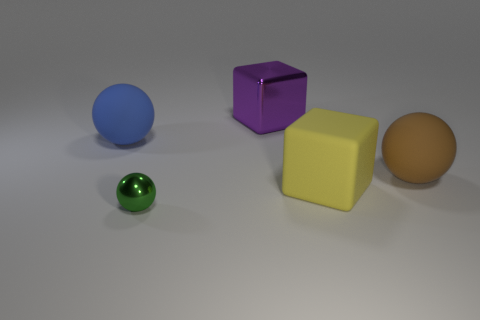Add 5 brown rubber objects. How many objects exist? 10 Subtract all spheres. How many objects are left? 2 Add 4 large purple metallic blocks. How many large purple metallic blocks exist? 5 Subtract 0 red spheres. How many objects are left? 5 Subtract all blue spheres. Subtract all blue objects. How many objects are left? 3 Add 2 brown matte things. How many brown matte things are left? 3 